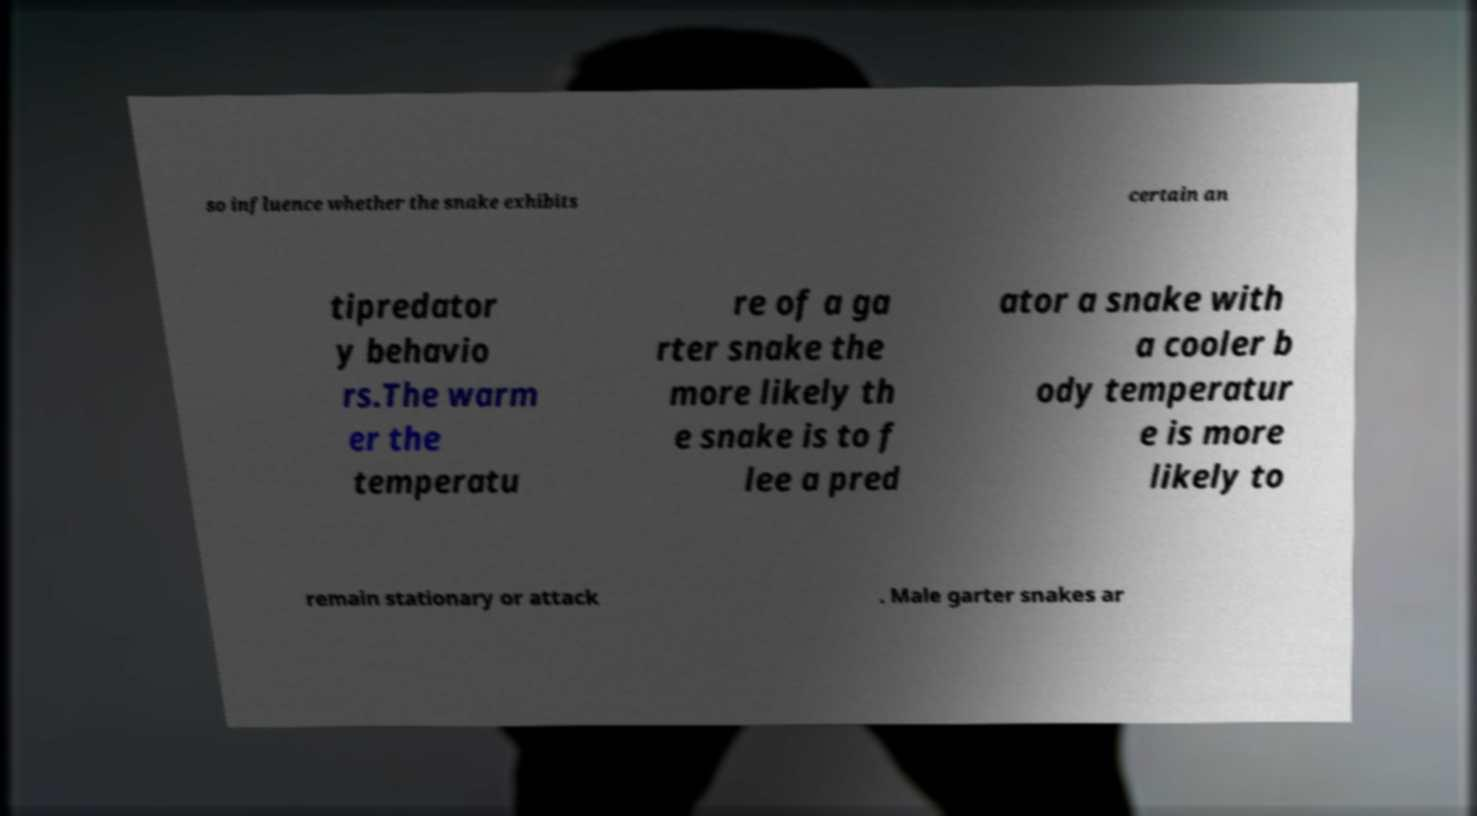Can you read and provide the text displayed in the image?This photo seems to have some interesting text. Can you extract and type it out for me? so influence whether the snake exhibits certain an tipredator y behavio rs.The warm er the temperatu re of a ga rter snake the more likely th e snake is to f lee a pred ator a snake with a cooler b ody temperatur e is more likely to remain stationary or attack . Male garter snakes ar 